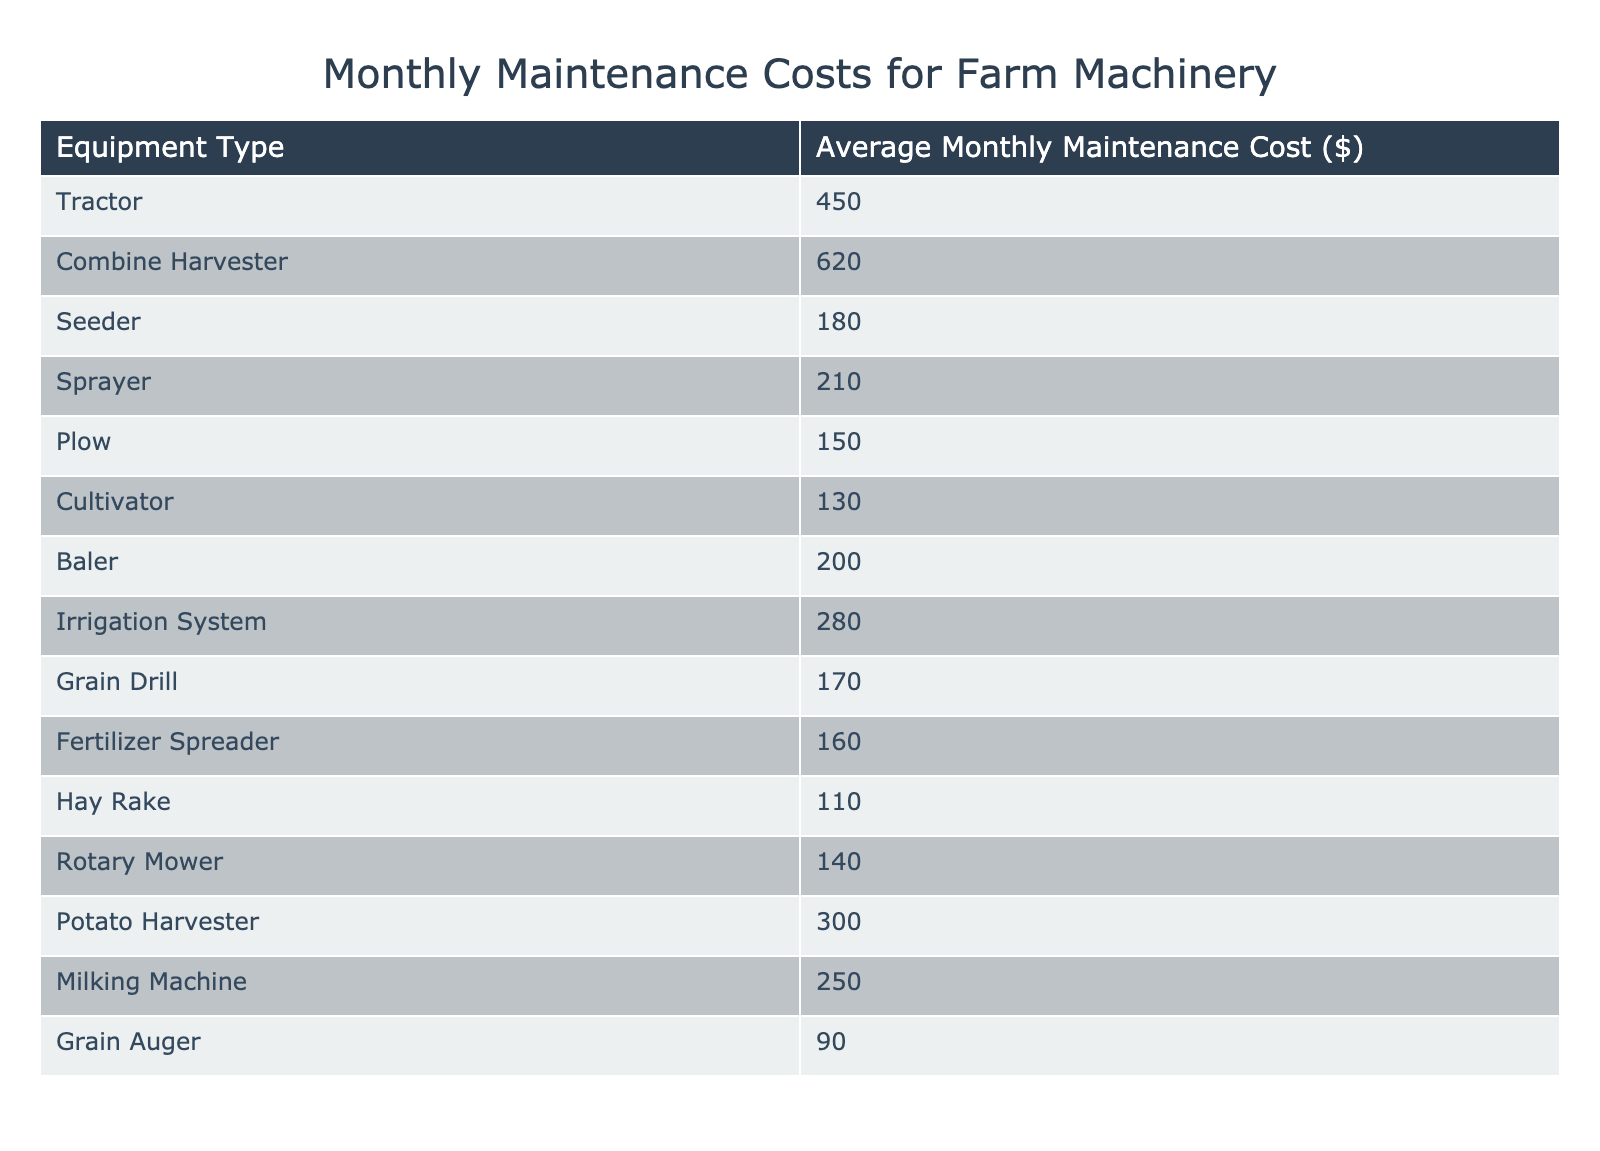What is the average monthly maintenance cost for a tractor? The table lists the average monthly maintenance cost for a tractor as 450 dollars.
Answer: 450 Which equipment type has the highest maintenance cost? By examining the table, the "Combine Harvester" has the highest average monthly maintenance cost, which is 620 dollars.
Answer: Combine Harvester How much does it cost to maintain a plow compared to a seeder? The average monthly maintenance cost for a plow is 150 dollars and for a seeder, it is 180 dollars. The plow costs 30 dollars less than the seeder (180 - 150 = 30).
Answer: 30 dollars less Is the average monthly maintenance cost for the irrigation system more than the average for the baler? The irrigation system costs 280 dollars, while the baler costs 200 dollars. Since 280 is greater than 200, the statement is true.
Answer: Yes What is the total maintenance cost of all the listed machinery? To find the total cost, we add up all the monthly maintenance costs: 450 + 620 + 180 + 210 + 150 + 130 + 200 + 280 + 170 + 160 + 110 + 140 + 300 + 250 + 90 = 2,870 dollars.
Answer: 2,870 dollars How does the average cost of maintaining a rotary mower compare to that of a grain auger? The rotary mower has a maintenance cost of 140 dollars while the grain auger costs 90 dollars. Thus, the rotary mower costs 50 dollars more than the grain auger (140 - 90 = 50).
Answer: 50 dollars more What is the median maintenance cost of the listed farm machinery? When arranging the costs in ascending order: 90, 110, 130, 140, 150, 160, 170, 180, 200, 210, 250, 280, 300, 450, 620, we see that there are 15 data points (odd number), thus the median will be the 8th value, which is 180 dollars.
Answer: 180 dollars Is the maintenance cost for the seeder lower than the irrigation system’s cost? The seeder costs 180 dollars, whereas the irrigation system costs 280 dollars. Hence, 180 is less than 280, making the statement true.
Answer: Yes Which equipment type has the lowest maintenance cost? According to the table, the "Grain Auger" has the lowest monthly maintenance cost at 90 dollars.
Answer: Grain Auger 